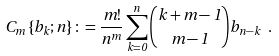<formula> <loc_0><loc_0><loc_500><loc_500>C _ { m } \left \{ b _ { k } ; n \right \} \colon = \frac { m ! } { n ^ { m } } \sum ^ { n } _ { k = 0 } \binom { k + m - 1 } { m - 1 } b _ { n - k } \ .</formula> 